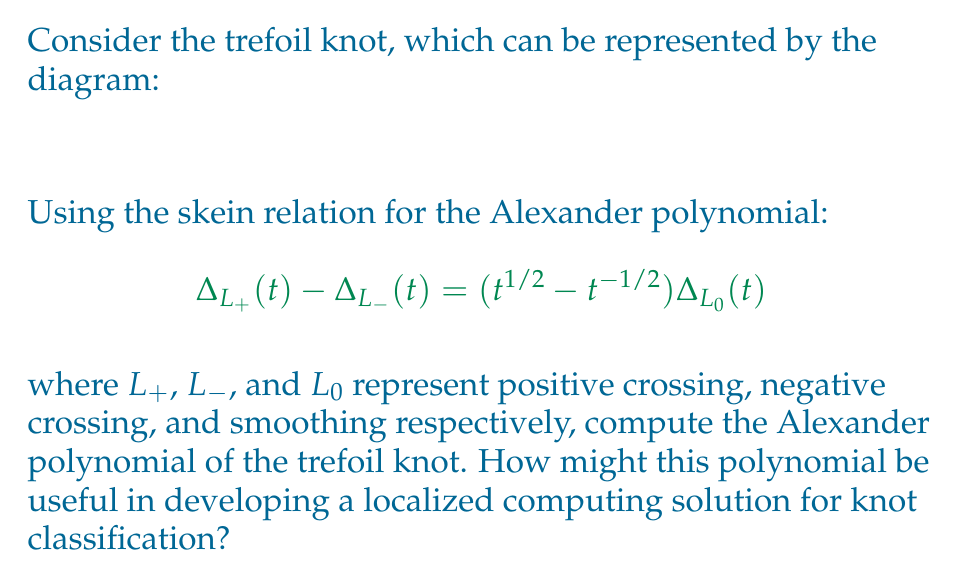Solve this math problem. Let's approach this step-by-step:

1) First, we need to identify the crossings in the trefoil knot. There are three positive crossings.

2) We'll use the skein relation at one of these crossings. Let $\Delta_+(t)$ be the Alexander polynomial of the trefoil, $\Delta_-(t)$ be the polynomial of the unknot (which results from changing one crossing), and $\Delta_0(t)$ be the polynomial of the two-component unlink (which results from smoothing the crossing).

3) We know that:
   - The Alexander polynomial of the unknot is 1: $\Delta_-(t) = 1$
   - The Alexander polynomial of the two-component unlink is 0: $\Delta_0(t) = 0$

4) Applying the skein relation:

   $$ \Delta_+(t) - 1 = (t^{1/2} - t^{-1/2}) \cdot 0 $$

5) Simplifying:

   $$ \Delta_+(t) = 1 $$

6) However, this is not the final answer. We've only resolved one crossing, and the trefoil has three. We need to apply the skein relation two more times.

7) After the second application:

   $$ \Delta_+(t) - 1 = (t^{1/2} - t^{-1/2}) \cdot 1 $$
   $$ \Delta_+(t) = 1 + (t^{1/2} - t^{-1/2}) = t^{1/2} - t^{-1/2} + 1 $$

8) And after the third application:

   $$ \Delta_+(t) - (t^{1/2} - t^{-1/2} + 1) = (t^{1/2} - t^{-1/2})(t^{1/2} - t^{-1/2} + 1) $$
   $$ \Delta_+(t) = (t^{1/2} - t^{-1/2} + 1) + (t^{1/2} - t^{-1/2})(t^{1/2} - t^{-1/2} + 1) $$
   $$ = (t^{1/2} - t^{-1/2} + 1)(1 + t^{1/2} - t^{-1/2}) $$
   $$ = t - 1 + t^{-1} $$

9) Therefore, the Alexander polynomial of the trefoil knot is $t - 1 + t^{-1}$.

For localized computing solutions, this polynomial could be used as a compact representation of the knot. It's a topological invariant, meaning it doesn't change under continuous deformations of the knot. This makes it useful for knot classification and comparison, which could be implemented efficiently in distributed systems. Each node in a network could compute or store Alexander polynomials for a subset of knots, allowing for parallel processing and localized decision-making in knot-related algorithms.
Answer: $t - 1 + t^{-1}$ 